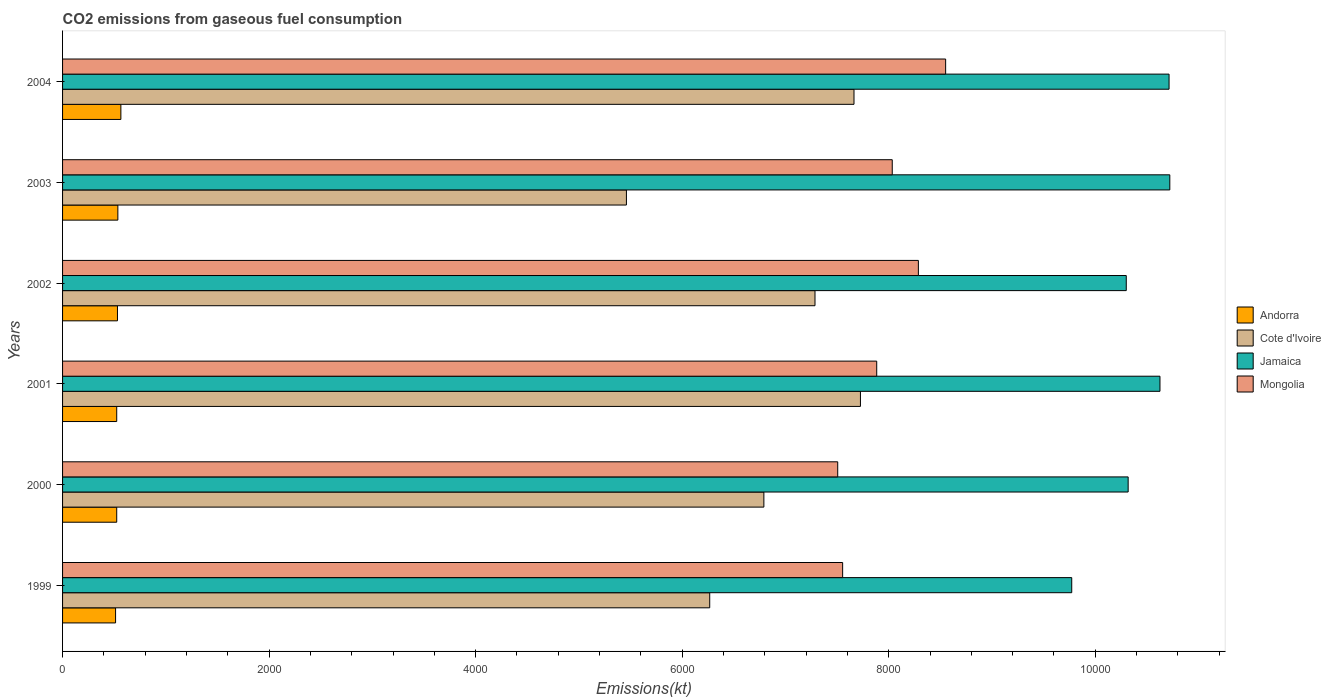How many different coloured bars are there?
Ensure brevity in your answer.  4. Are the number of bars on each tick of the Y-axis equal?
Offer a terse response. Yes. How many bars are there on the 6th tick from the top?
Offer a terse response. 4. How many bars are there on the 3rd tick from the bottom?
Offer a very short reply. 4. In how many cases, is the number of bars for a given year not equal to the number of legend labels?
Provide a short and direct response. 0. What is the amount of CO2 emitted in Mongolia in 1999?
Provide a short and direct response. 7554.02. Across all years, what is the maximum amount of CO2 emitted in Cote d'Ivoire?
Your response must be concise. 7726.37. Across all years, what is the minimum amount of CO2 emitted in Jamaica?
Your response must be concise. 9772.56. What is the total amount of CO2 emitted in Jamaica in the graph?
Your answer should be very brief. 6.25e+04. What is the difference between the amount of CO2 emitted in Mongolia in 2000 and that in 2001?
Your answer should be very brief. -377.7. What is the difference between the amount of CO2 emitted in Mongolia in 2003 and the amount of CO2 emitted in Jamaica in 2002?
Keep it short and to the point. -2266.21. What is the average amount of CO2 emitted in Jamaica per year?
Offer a terse response. 1.04e+04. In the year 2001, what is the difference between the amount of CO2 emitted in Cote d'Ivoire and amount of CO2 emitted in Jamaica?
Offer a very short reply. -2900.6. In how many years, is the amount of CO2 emitted in Cote d'Ivoire greater than 10400 kt?
Provide a short and direct response. 0. What is the ratio of the amount of CO2 emitted in Jamaica in 1999 to that in 2003?
Give a very brief answer. 0.91. Is the amount of CO2 emitted in Andorra in 2001 less than that in 2004?
Ensure brevity in your answer.  Yes. Is the difference between the amount of CO2 emitted in Cote d'Ivoire in 1999 and 2002 greater than the difference between the amount of CO2 emitted in Jamaica in 1999 and 2002?
Ensure brevity in your answer.  No. What is the difference between the highest and the second highest amount of CO2 emitted in Andorra?
Give a very brief answer. 29.34. What is the difference between the highest and the lowest amount of CO2 emitted in Mongolia?
Keep it short and to the point. 1045.09. Is the sum of the amount of CO2 emitted in Cote d'Ivoire in 1999 and 2003 greater than the maximum amount of CO2 emitted in Andorra across all years?
Make the answer very short. Yes. What does the 2nd bar from the top in 1999 represents?
Offer a very short reply. Jamaica. What does the 4th bar from the bottom in 1999 represents?
Give a very brief answer. Mongolia. How many bars are there?
Give a very brief answer. 24. Are all the bars in the graph horizontal?
Offer a terse response. Yes. What is the difference between two consecutive major ticks on the X-axis?
Offer a terse response. 2000. Are the values on the major ticks of X-axis written in scientific E-notation?
Make the answer very short. No. Does the graph contain any zero values?
Give a very brief answer. No. How many legend labels are there?
Offer a very short reply. 4. How are the legend labels stacked?
Provide a short and direct response. Vertical. What is the title of the graph?
Your response must be concise. CO2 emissions from gaseous fuel consumption. Does "Belgium" appear as one of the legend labels in the graph?
Offer a terse response. No. What is the label or title of the X-axis?
Offer a terse response. Emissions(kt). What is the Emissions(kt) in Andorra in 1999?
Your answer should be very brief. 513.38. What is the Emissions(kt) of Cote d'Ivoire in 1999?
Ensure brevity in your answer.  6266.9. What is the Emissions(kt) of Jamaica in 1999?
Make the answer very short. 9772.56. What is the Emissions(kt) of Mongolia in 1999?
Make the answer very short. 7554.02. What is the Emissions(kt) in Andorra in 2000?
Your response must be concise. 524.38. What is the Emissions(kt) of Cote d'Ivoire in 2000?
Your answer should be compact. 6791.28. What is the Emissions(kt) in Jamaica in 2000?
Offer a very short reply. 1.03e+04. What is the Emissions(kt) of Mongolia in 2000?
Keep it short and to the point. 7506.35. What is the Emissions(kt) of Andorra in 2001?
Offer a very short reply. 524.38. What is the Emissions(kt) of Cote d'Ivoire in 2001?
Your answer should be compact. 7726.37. What is the Emissions(kt) in Jamaica in 2001?
Ensure brevity in your answer.  1.06e+04. What is the Emissions(kt) in Mongolia in 2001?
Make the answer very short. 7884.05. What is the Emissions(kt) in Andorra in 2002?
Make the answer very short. 531.72. What is the Emissions(kt) of Cote d'Ivoire in 2002?
Your answer should be very brief. 7286.33. What is the Emissions(kt) in Jamaica in 2002?
Your response must be concise. 1.03e+04. What is the Emissions(kt) in Mongolia in 2002?
Ensure brevity in your answer.  8287.42. What is the Emissions(kt) of Andorra in 2003?
Give a very brief answer. 535.38. What is the Emissions(kt) of Cote d'Ivoire in 2003?
Provide a short and direct response. 5460.16. What is the Emissions(kt) of Jamaica in 2003?
Your answer should be compact. 1.07e+04. What is the Emissions(kt) of Mongolia in 2003?
Your answer should be compact. 8034.4. What is the Emissions(kt) of Andorra in 2004?
Provide a succinct answer. 564.72. What is the Emissions(kt) in Cote d'Ivoire in 2004?
Ensure brevity in your answer.  7664.03. What is the Emissions(kt) in Jamaica in 2004?
Your answer should be compact. 1.07e+04. What is the Emissions(kt) in Mongolia in 2004?
Your answer should be very brief. 8551.44. Across all years, what is the maximum Emissions(kt) of Andorra?
Provide a short and direct response. 564.72. Across all years, what is the maximum Emissions(kt) of Cote d'Ivoire?
Make the answer very short. 7726.37. Across all years, what is the maximum Emissions(kt) of Jamaica?
Offer a terse response. 1.07e+04. Across all years, what is the maximum Emissions(kt) in Mongolia?
Make the answer very short. 8551.44. Across all years, what is the minimum Emissions(kt) in Andorra?
Make the answer very short. 513.38. Across all years, what is the minimum Emissions(kt) in Cote d'Ivoire?
Provide a short and direct response. 5460.16. Across all years, what is the minimum Emissions(kt) in Jamaica?
Give a very brief answer. 9772.56. Across all years, what is the minimum Emissions(kt) of Mongolia?
Make the answer very short. 7506.35. What is the total Emissions(kt) of Andorra in the graph?
Offer a very short reply. 3193.96. What is the total Emissions(kt) of Cote d'Ivoire in the graph?
Make the answer very short. 4.12e+04. What is the total Emissions(kt) in Jamaica in the graph?
Give a very brief answer. 6.25e+04. What is the total Emissions(kt) of Mongolia in the graph?
Give a very brief answer. 4.78e+04. What is the difference between the Emissions(kt) of Andorra in 1999 and that in 2000?
Your response must be concise. -11. What is the difference between the Emissions(kt) in Cote d'Ivoire in 1999 and that in 2000?
Your response must be concise. -524.38. What is the difference between the Emissions(kt) of Jamaica in 1999 and that in 2000?
Your answer should be very brief. -546.38. What is the difference between the Emissions(kt) in Mongolia in 1999 and that in 2000?
Make the answer very short. 47.67. What is the difference between the Emissions(kt) of Andorra in 1999 and that in 2001?
Make the answer very short. -11. What is the difference between the Emissions(kt) in Cote d'Ivoire in 1999 and that in 2001?
Your answer should be compact. -1459.47. What is the difference between the Emissions(kt) in Jamaica in 1999 and that in 2001?
Offer a terse response. -854.41. What is the difference between the Emissions(kt) in Mongolia in 1999 and that in 2001?
Keep it short and to the point. -330.03. What is the difference between the Emissions(kt) of Andorra in 1999 and that in 2002?
Offer a very short reply. -18.34. What is the difference between the Emissions(kt) in Cote d'Ivoire in 1999 and that in 2002?
Offer a terse response. -1019.43. What is the difference between the Emissions(kt) of Jamaica in 1999 and that in 2002?
Your response must be concise. -528.05. What is the difference between the Emissions(kt) of Mongolia in 1999 and that in 2002?
Offer a terse response. -733.4. What is the difference between the Emissions(kt) in Andorra in 1999 and that in 2003?
Offer a very short reply. -22. What is the difference between the Emissions(kt) of Cote d'Ivoire in 1999 and that in 2003?
Keep it short and to the point. 806.74. What is the difference between the Emissions(kt) of Jamaica in 1999 and that in 2003?
Your answer should be compact. -949.75. What is the difference between the Emissions(kt) of Mongolia in 1999 and that in 2003?
Offer a very short reply. -480.38. What is the difference between the Emissions(kt) in Andorra in 1999 and that in 2004?
Ensure brevity in your answer.  -51.34. What is the difference between the Emissions(kt) in Cote d'Ivoire in 1999 and that in 2004?
Give a very brief answer. -1397.13. What is the difference between the Emissions(kt) in Jamaica in 1999 and that in 2004?
Offer a very short reply. -942.42. What is the difference between the Emissions(kt) in Mongolia in 1999 and that in 2004?
Your answer should be compact. -997.42. What is the difference between the Emissions(kt) in Cote d'Ivoire in 2000 and that in 2001?
Provide a succinct answer. -935.09. What is the difference between the Emissions(kt) of Jamaica in 2000 and that in 2001?
Your answer should be very brief. -308.03. What is the difference between the Emissions(kt) of Mongolia in 2000 and that in 2001?
Make the answer very short. -377.7. What is the difference between the Emissions(kt) of Andorra in 2000 and that in 2002?
Provide a short and direct response. -7.33. What is the difference between the Emissions(kt) of Cote d'Ivoire in 2000 and that in 2002?
Offer a terse response. -495.05. What is the difference between the Emissions(kt) of Jamaica in 2000 and that in 2002?
Your answer should be compact. 18.34. What is the difference between the Emissions(kt) of Mongolia in 2000 and that in 2002?
Your response must be concise. -781.07. What is the difference between the Emissions(kt) of Andorra in 2000 and that in 2003?
Make the answer very short. -11. What is the difference between the Emissions(kt) of Cote d'Ivoire in 2000 and that in 2003?
Provide a succinct answer. 1331.12. What is the difference between the Emissions(kt) of Jamaica in 2000 and that in 2003?
Your answer should be compact. -403.37. What is the difference between the Emissions(kt) in Mongolia in 2000 and that in 2003?
Offer a terse response. -528.05. What is the difference between the Emissions(kt) of Andorra in 2000 and that in 2004?
Provide a short and direct response. -40.34. What is the difference between the Emissions(kt) of Cote d'Ivoire in 2000 and that in 2004?
Offer a terse response. -872.75. What is the difference between the Emissions(kt) of Jamaica in 2000 and that in 2004?
Offer a terse response. -396.04. What is the difference between the Emissions(kt) of Mongolia in 2000 and that in 2004?
Offer a very short reply. -1045.1. What is the difference between the Emissions(kt) of Andorra in 2001 and that in 2002?
Your response must be concise. -7.33. What is the difference between the Emissions(kt) in Cote d'Ivoire in 2001 and that in 2002?
Keep it short and to the point. 440.04. What is the difference between the Emissions(kt) in Jamaica in 2001 and that in 2002?
Give a very brief answer. 326.36. What is the difference between the Emissions(kt) of Mongolia in 2001 and that in 2002?
Ensure brevity in your answer.  -403.37. What is the difference between the Emissions(kt) of Andorra in 2001 and that in 2003?
Provide a short and direct response. -11. What is the difference between the Emissions(kt) in Cote d'Ivoire in 2001 and that in 2003?
Your response must be concise. 2266.21. What is the difference between the Emissions(kt) of Jamaica in 2001 and that in 2003?
Ensure brevity in your answer.  -95.34. What is the difference between the Emissions(kt) of Mongolia in 2001 and that in 2003?
Offer a terse response. -150.35. What is the difference between the Emissions(kt) of Andorra in 2001 and that in 2004?
Give a very brief answer. -40.34. What is the difference between the Emissions(kt) of Cote d'Ivoire in 2001 and that in 2004?
Make the answer very short. 62.34. What is the difference between the Emissions(kt) in Jamaica in 2001 and that in 2004?
Make the answer very short. -88.01. What is the difference between the Emissions(kt) in Mongolia in 2001 and that in 2004?
Offer a very short reply. -667.39. What is the difference between the Emissions(kt) in Andorra in 2002 and that in 2003?
Give a very brief answer. -3.67. What is the difference between the Emissions(kt) in Cote d'Ivoire in 2002 and that in 2003?
Your answer should be very brief. 1826.17. What is the difference between the Emissions(kt) in Jamaica in 2002 and that in 2003?
Your response must be concise. -421.7. What is the difference between the Emissions(kt) of Mongolia in 2002 and that in 2003?
Make the answer very short. 253.02. What is the difference between the Emissions(kt) of Andorra in 2002 and that in 2004?
Your answer should be compact. -33. What is the difference between the Emissions(kt) of Cote d'Ivoire in 2002 and that in 2004?
Your answer should be very brief. -377.7. What is the difference between the Emissions(kt) of Jamaica in 2002 and that in 2004?
Your response must be concise. -414.37. What is the difference between the Emissions(kt) in Mongolia in 2002 and that in 2004?
Give a very brief answer. -264.02. What is the difference between the Emissions(kt) of Andorra in 2003 and that in 2004?
Provide a short and direct response. -29.34. What is the difference between the Emissions(kt) of Cote d'Ivoire in 2003 and that in 2004?
Ensure brevity in your answer.  -2203.87. What is the difference between the Emissions(kt) in Jamaica in 2003 and that in 2004?
Keep it short and to the point. 7.33. What is the difference between the Emissions(kt) in Mongolia in 2003 and that in 2004?
Offer a very short reply. -517.05. What is the difference between the Emissions(kt) in Andorra in 1999 and the Emissions(kt) in Cote d'Ivoire in 2000?
Offer a terse response. -6277.9. What is the difference between the Emissions(kt) of Andorra in 1999 and the Emissions(kt) of Jamaica in 2000?
Offer a very short reply. -9805.56. What is the difference between the Emissions(kt) in Andorra in 1999 and the Emissions(kt) in Mongolia in 2000?
Your response must be concise. -6992.97. What is the difference between the Emissions(kt) of Cote d'Ivoire in 1999 and the Emissions(kt) of Jamaica in 2000?
Provide a short and direct response. -4052.03. What is the difference between the Emissions(kt) in Cote d'Ivoire in 1999 and the Emissions(kt) in Mongolia in 2000?
Offer a very short reply. -1239.45. What is the difference between the Emissions(kt) of Jamaica in 1999 and the Emissions(kt) of Mongolia in 2000?
Offer a very short reply. 2266.21. What is the difference between the Emissions(kt) in Andorra in 1999 and the Emissions(kt) in Cote d'Ivoire in 2001?
Offer a very short reply. -7212.99. What is the difference between the Emissions(kt) of Andorra in 1999 and the Emissions(kt) of Jamaica in 2001?
Make the answer very short. -1.01e+04. What is the difference between the Emissions(kt) in Andorra in 1999 and the Emissions(kt) in Mongolia in 2001?
Offer a terse response. -7370.67. What is the difference between the Emissions(kt) of Cote d'Ivoire in 1999 and the Emissions(kt) of Jamaica in 2001?
Offer a terse response. -4360.06. What is the difference between the Emissions(kt) of Cote d'Ivoire in 1999 and the Emissions(kt) of Mongolia in 2001?
Your answer should be compact. -1617.15. What is the difference between the Emissions(kt) of Jamaica in 1999 and the Emissions(kt) of Mongolia in 2001?
Make the answer very short. 1888.51. What is the difference between the Emissions(kt) of Andorra in 1999 and the Emissions(kt) of Cote d'Ivoire in 2002?
Make the answer very short. -6772.95. What is the difference between the Emissions(kt) of Andorra in 1999 and the Emissions(kt) of Jamaica in 2002?
Keep it short and to the point. -9787.22. What is the difference between the Emissions(kt) in Andorra in 1999 and the Emissions(kt) in Mongolia in 2002?
Ensure brevity in your answer.  -7774.04. What is the difference between the Emissions(kt) in Cote d'Ivoire in 1999 and the Emissions(kt) in Jamaica in 2002?
Keep it short and to the point. -4033.7. What is the difference between the Emissions(kt) of Cote d'Ivoire in 1999 and the Emissions(kt) of Mongolia in 2002?
Provide a short and direct response. -2020.52. What is the difference between the Emissions(kt) in Jamaica in 1999 and the Emissions(kt) in Mongolia in 2002?
Provide a short and direct response. 1485.13. What is the difference between the Emissions(kt) of Andorra in 1999 and the Emissions(kt) of Cote d'Ivoire in 2003?
Give a very brief answer. -4946.78. What is the difference between the Emissions(kt) in Andorra in 1999 and the Emissions(kt) in Jamaica in 2003?
Your response must be concise. -1.02e+04. What is the difference between the Emissions(kt) of Andorra in 1999 and the Emissions(kt) of Mongolia in 2003?
Make the answer very short. -7521.02. What is the difference between the Emissions(kt) in Cote d'Ivoire in 1999 and the Emissions(kt) in Jamaica in 2003?
Your answer should be compact. -4455.4. What is the difference between the Emissions(kt) of Cote d'Ivoire in 1999 and the Emissions(kt) of Mongolia in 2003?
Provide a succinct answer. -1767.49. What is the difference between the Emissions(kt) of Jamaica in 1999 and the Emissions(kt) of Mongolia in 2003?
Your answer should be compact. 1738.16. What is the difference between the Emissions(kt) in Andorra in 1999 and the Emissions(kt) in Cote d'Ivoire in 2004?
Make the answer very short. -7150.65. What is the difference between the Emissions(kt) of Andorra in 1999 and the Emissions(kt) of Jamaica in 2004?
Your answer should be very brief. -1.02e+04. What is the difference between the Emissions(kt) in Andorra in 1999 and the Emissions(kt) in Mongolia in 2004?
Your answer should be compact. -8038.06. What is the difference between the Emissions(kt) of Cote d'Ivoire in 1999 and the Emissions(kt) of Jamaica in 2004?
Ensure brevity in your answer.  -4448.07. What is the difference between the Emissions(kt) of Cote d'Ivoire in 1999 and the Emissions(kt) of Mongolia in 2004?
Your response must be concise. -2284.54. What is the difference between the Emissions(kt) in Jamaica in 1999 and the Emissions(kt) in Mongolia in 2004?
Provide a succinct answer. 1221.11. What is the difference between the Emissions(kt) of Andorra in 2000 and the Emissions(kt) of Cote d'Ivoire in 2001?
Provide a short and direct response. -7201.99. What is the difference between the Emissions(kt) in Andorra in 2000 and the Emissions(kt) in Jamaica in 2001?
Provide a succinct answer. -1.01e+04. What is the difference between the Emissions(kt) of Andorra in 2000 and the Emissions(kt) of Mongolia in 2001?
Offer a terse response. -7359.67. What is the difference between the Emissions(kt) in Cote d'Ivoire in 2000 and the Emissions(kt) in Jamaica in 2001?
Offer a very short reply. -3835.68. What is the difference between the Emissions(kt) in Cote d'Ivoire in 2000 and the Emissions(kt) in Mongolia in 2001?
Provide a short and direct response. -1092.77. What is the difference between the Emissions(kt) of Jamaica in 2000 and the Emissions(kt) of Mongolia in 2001?
Offer a terse response. 2434.89. What is the difference between the Emissions(kt) of Andorra in 2000 and the Emissions(kt) of Cote d'Ivoire in 2002?
Offer a terse response. -6761.95. What is the difference between the Emissions(kt) of Andorra in 2000 and the Emissions(kt) of Jamaica in 2002?
Ensure brevity in your answer.  -9776.22. What is the difference between the Emissions(kt) of Andorra in 2000 and the Emissions(kt) of Mongolia in 2002?
Provide a short and direct response. -7763.04. What is the difference between the Emissions(kt) of Cote d'Ivoire in 2000 and the Emissions(kt) of Jamaica in 2002?
Make the answer very short. -3509.32. What is the difference between the Emissions(kt) of Cote d'Ivoire in 2000 and the Emissions(kt) of Mongolia in 2002?
Make the answer very short. -1496.14. What is the difference between the Emissions(kt) of Jamaica in 2000 and the Emissions(kt) of Mongolia in 2002?
Keep it short and to the point. 2031.52. What is the difference between the Emissions(kt) in Andorra in 2000 and the Emissions(kt) in Cote d'Ivoire in 2003?
Offer a terse response. -4935.78. What is the difference between the Emissions(kt) of Andorra in 2000 and the Emissions(kt) of Jamaica in 2003?
Provide a succinct answer. -1.02e+04. What is the difference between the Emissions(kt) of Andorra in 2000 and the Emissions(kt) of Mongolia in 2003?
Give a very brief answer. -7510.02. What is the difference between the Emissions(kt) of Cote d'Ivoire in 2000 and the Emissions(kt) of Jamaica in 2003?
Ensure brevity in your answer.  -3931.02. What is the difference between the Emissions(kt) of Cote d'Ivoire in 2000 and the Emissions(kt) of Mongolia in 2003?
Offer a very short reply. -1243.11. What is the difference between the Emissions(kt) of Jamaica in 2000 and the Emissions(kt) of Mongolia in 2003?
Offer a terse response. 2284.54. What is the difference between the Emissions(kt) of Andorra in 2000 and the Emissions(kt) of Cote d'Ivoire in 2004?
Ensure brevity in your answer.  -7139.65. What is the difference between the Emissions(kt) in Andorra in 2000 and the Emissions(kt) in Jamaica in 2004?
Keep it short and to the point. -1.02e+04. What is the difference between the Emissions(kt) in Andorra in 2000 and the Emissions(kt) in Mongolia in 2004?
Your answer should be very brief. -8027.06. What is the difference between the Emissions(kt) of Cote d'Ivoire in 2000 and the Emissions(kt) of Jamaica in 2004?
Give a very brief answer. -3923.69. What is the difference between the Emissions(kt) of Cote d'Ivoire in 2000 and the Emissions(kt) of Mongolia in 2004?
Keep it short and to the point. -1760.16. What is the difference between the Emissions(kt) of Jamaica in 2000 and the Emissions(kt) of Mongolia in 2004?
Offer a very short reply. 1767.49. What is the difference between the Emissions(kt) of Andorra in 2001 and the Emissions(kt) of Cote d'Ivoire in 2002?
Your answer should be compact. -6761.95. What is the difference between the Emissions(kt) of Andorra in 2001 and the Emissions(kt) of Jamaica in 2002?
Provide a succinct answer. -9776.22. What is the difference between the Emissions(kt) of Andorra in 2001 and the Emissions(kt) of Mongolia in 2002?
Your response must be concise. -7763.04. What is the difference between the Emissions(kt) in Cote d'Ivoire in 2001 and the Emissions(kt) in Jamaica in 2002?
Offer a terse response. -2574.23. What is the difference between the Emissions(kt) in Cote d'Ivoire in 2001 and the Emissions(kt) in Mongolia in 2002?
Keep it short and to the point. -561.05. What is the difference between the Emissions(kt) in Jamaica in 2001 and the Emissions(kt) in Mongolia in 2002?
Make the answer very short. 2339.55. What is the difference between the Emissions(kt) in Andorra in 2001 and the Emissions(kt) in Cote d'Ivoire in 2003?
Offer a very short reply. -4935.78. What is the difference between the Emissions(kt) of Andorra in 2001 and the Emissions(kt) of Jamaica in 2003?
Offer a very short reply. -1.02e+04. What is the difference between the Emissions(kt) of Andorra in 2001 and the Emissions(kt) of Mongolia in 2003?
Offer a very short reply. -7510.02. What is the difference between the Emissions(kt) of Cote d'Ivoire in 2001 and the Emissions(kt) of Jamaica in 2003?
Your response must be concise. -2995.94. What is the difference between the Emissions(kt) in Cote d'Ivoire in 2001 and the Emissions(kt) in Mongolia in 2003?
Give a very brief answer. -308.03. What is the difference between the Emissions(kt) of Jamaica in 2001 and the Emissions(kt) of Mongolia in 2003?
Give a very brief answer. 2592.57. What is the difference between the Emissions(kt) of Andorra in 2001 and the Emissions(kt) of Cote d'Ivoire in 2004?
Offer a terse response. -7139.65. What is the difference between the Emissions(kt) of Andorra in 2001 and the Emissions(kt) of Jamaica in 2004?
Keep it short and to the point. -1.02e+04. What is the difference between the Emissions(kt) in Andorra in 2001 and the Emissions(kt) in Mongolia in 2004?
Provide a succinct answer. -8027.06. What is the difference between the Emissions(kt) of Cote d'Ivoire in 2001 and the Emissions(kt) of Jamaica in 2004?
Offer a very short reply. -2988.61. What is the difference between the Emissions(kt) in Cote d'Ivoire in 2001 and the Emissions(kt) in Mongolia in 2004?
Your response must be concise. -825.08. What is the difference between the Emissions(kt) of Jamaica in 2001 and the Emissions(kt) of Mongolia in 2004?
Offer a terse response. 2075.52. What is the difference between the Emissions(kt) of Andorra in 2002 and the Emissions(kt) of Cote d'Ivoire in 2003?
Give a very brief answer. -4928.45. What is the difference between the Emissions(kt) in Andorra in 2002 and the Emissions(kt) in Jamaica in 2003?
Your answer should be compact. -1.02e+04. What is the difference between the Emissions(kt) in Andorra in 2002 and the Emissions(kt) in Mongolia in 2003?
Provide a short and direct response. -7502.68. What is the difference between the Emissions(kt) in Cote d'Ivoire in 2002 and the Emissions(kt) in Jamaica in 2003?
Your answer should be compact. -3435.98. What is the difference between the Emissions(kt) of Cote d'Ivoire in 2002 and the Emissions(kt) of Mongolia in 2003?
Make the answer very short. -748.07. What is the difference between the Emissions(kt) of Jamaica in 2002 and the Emissions(kt) of Mongolia in 2003?
Provide a short and direct response. 2266.21. What is the difference between the Emissions(kt) of Andorra in 2002 and the Emissions(kt) of Cote d'Ivoire in 2004?
Your answer should be compact. -7132.31. What is the difference between the Emissions(kt) of Andorra in 2002 and the Emissions(kt) of Jamaica in 2004?
Offer a very short reply. -1.02e+04. What is the difference between the Emissions(kt) of Andorra in 2002 and the Emissions(kt) of Mongolia in 2004?
Make the answer very short. -8019.73. What is the difference between the Emissions(kt) in Cote d'Ivoire in 2002 and the Emissions(kt) in Jamaica in 2004?
Make the answer very short. -3428.64. What is the difference between the Emissions(kt) in Cote d'Ivoire in 2002 and the Emissions(kt) in Mongolia in 2004?
Ensure brevity in your answer.  -1265.12. What is the difference between the Emissions(kt) in Jamaica in 2002 and the Emissions(kt) in Mongolia in 2004?
Keep it short and to the point. 1749.16. What is the difference between the Emissions(kt) in Andorra in 2003 and the Emissions(kt) in Cote d'Ivoire in 2004?
Ensure brevity in your answer.  -7128.65. What is the difference between the Emissions(kt) in Andorra in 2003 and the Emissions(kt) in Jamaica in 2004?
Your answer should be compact. -1.02e+04. What is the difference between the Emissions(kt) in Andorra in 2003 and the Emissions(kt) in Mongolia in 2004?
Offer a very short reply. -8016.06. What is the difference between the Emissions(kt) of Cote d'Ivoire in 2003 and the Emissions(kt) of Jamaica in 2004?
Provide a succinct answer. -5254.81. What is the difference between the Emissions(kt) of Cote d'Ivoire in 2003 and the Emissions(kt) of Mongolia in 2004?
Offer a terse response. -3091.28. What is the difference between the Emissions(kt) in Jamaica in 2003 and the Emissions(kt) in Mongolia in 2004?
Provide a succinct answer. 2170.86. What is the average Emissions(kt) of Andorra per year?
Make the answer very short. 532.33. What is the average Emissions(kt) in Cote d'Ivoire per year?
Offer a very short reply. 6865.85. What is the average Emissions(kt) in Jamaica per year?
Provide a short and direct response. 1.04e+04. What is the average Emissions(kt) in Mongolia per year?
Make the answer very short. 7969.61. In the year 1999, what is the difference between the Emissions(kt) in Andorra and Emissions(kt) in Cote d'Ivoire?
Your answer should be very brief. -5753.52. In the year 1999, what is the difference between the Emissions(kt) of Andorra and Emissions(kt) of Jamaica?
Your response must be concise. -9259.17. In the year 1999, what is the difference between the Emissions(kt) of Andorra and Emissions(kt) of Mongolia?
Offer a very short reply. -7040.64. In the year 1999, what is the difference between the Emissions(kt) in Cote d'Ivoire and Emissions(kt) in Jamaica?
Offer a terse response. -3505.65. In the year 1999, what is the difference between the Emissions(kt) in Cote d'Ivoire and Emissions(kt) in Mongolia?
Ensure brevity in your answer.  -1287.12. In the year 1999, what is the difference between the Emissions(kt) in Jamaica and Emissions(kt) in Mongolia?
Provide a succinct answer. 2218.53. In the year 2000, what is the difference between the Emissions(kt) in Andorra and Emissions(kt) in Cote d'Ivoire?
Offer a terse response. -6266.9. In the year 2000, what is the difference between the Emissions(kt) of Andorra and Emissions(kt) of Jamaica?
Your answer should be very brief. -9794.56. In the year 2000, what is the difference between the Emissions(kt) of Andorra and Emissions(kt) of Mongolia?
Your response must be concise. -6981.97. In the year 2000, what is the difference between the Emissions(kt) of Cote d'Ivoire and Emissions(kt) of Jamaica?
Your answer should be very brief. -3527.65. In the year 2000, what is the difference between the Emissions(kt) of Cote d'Ivoire and Emissions(kt) of Mongolia?
Offer a very short reply. -715.07. In the year 2000, what is the difference between the Emissions(kt) in Jamaica and Emissions(kt) in Mongolia?
Provide a short and direct response. 2812.59. In the year 2001, what is the difference between the Emissions(kt) of Andorra and Emissions(kt) of Cote d'Ivoire?
Offer a very short reply. -7201.99. In the year 2001, what is the difference between the Emissions(kt) of Andorra and Emissions(kt) of Jamaica?
Give a very brief answer. -1.01e+04. In the year 2001, what is the difference between the Emissions(kt) of Andorra and Emissions(kt) of Mongolia?
Ensure brevity in your answer.  -7359.67. In the year 2001, what is the difference between the Emissions(kt) in Cote d'Ivoire and Emissions(kt) in Jamaica?
Keep it short and to the point. -2900.6. In the year 2001, what is the difference between the Emissions(kt) of Cote d'Ivoire and Emissions(kt) of Mongolia?
Keep it short and to the point. -157.68. In the year 2001, what is the difference between the Emissions(kt) of Jamaica and Emissions(kt) of Mongolia?
Provide a succinct answer. 2742.92. In the year 2002, what is the difference between the Emissions(kt) of Andorra and Emissions(kt) of Cote d'Ivoire?
Your response must be concise. -6754.61. In the year 2002, what is the difference between the Emissions(kt) in Andorra and Emissions(kt) in Jamaica?
Make the answer very short. -9768.89. In the year 2002, what is the difference between the Emissions(kt) in Andorra and Emissions(kt) in Mongolia?
Keep it short and to the point. -7755.7. In the year 2002, what is the difference between the Emissions(kt) in Cote d'Ivoire and Emissions(kt) in Jamaica?
Offer a terse response. -3014.27. In the year 2002, what is the difference between the Emissions(kt) of Cote d'Ivoire and Emissions(kt) of Mongolia?
Provide a short and direct response. -1001.09. In the year 2002, what is the difference between the Emissions(kt) in Jamaica and Emissions(kt) in Mongolia?
Provide a short and direct response. 2013.18. In the year 2003, what is the difference between the Emissions(kt) in Andorra and Emissions(kt) in Cote d'Ivoire?
Provide a short and direct response. -4924.78. In the year 2003, what is the difference between the Emissions(kt) in Andorra and Emissions(kt) in Jamaica?
Offer a very short reply. -1.02e+04. In the year 2003, what is the difference between the Emissions(kt) of Andorra and Emissions(kt) of Mongolia?
Keep it short and to the point. -7499.02. In the year 2003, what is the difference between the Emissions(kt) of Cote d'Ivoire and Emissions(kt) of Jamaica?
Offer a terse response. -5262.15. In the year 2003, what is the difference between the Emissions(kt) of Cote d'Ivoire and Emissions(kt) of Mongolia?
Provide a succinct answer. -2574.23. In the year 2003, what is the difference between the Emissions(kt) in Jamaica and Emissions(kt) in Mongolia?
Offer a very short reply. 2687.91. In the year 2004, what is the difference between the Emissions(kt) of Andorra and Emissions(kt) of Cote d'Ivoire?
Provide a short and direct response. -7099.31. In the year 2004, what is the difference between the Emissions(kt) in Andorra and Emissions(kt) in Jamaica?
Provide a short and direct response. -1.02e+04. In the year 2004, what is the difference between the Emissions(kt) of Andorra and Emissions(kt) of Mongolia?
Your answer should be very brief. -7986.73. In the year 2004, what is the difference between the Emissions(kt) in Cote d'Ivoire and Emissions(kt) in Jamaica?
Your answer should be compact. -3050.94. In the year 2004, what is the difference between the Emissions(kt) of Cote d'Ivoire and Emissions(kt) of Mongolia?
Keep it short and to the point. -887.41. In the year 2004, what is the difference between the Emissions(kt) in Jamaica and Emissions(kt) in Mongolia?
Your answer should be very brief. 2163.53. What is the ratio of the Emissions(kt) in Andorra in 1999 to that in 2000?
Your response must be concise. 0.98. What is the ratio of the Emissions(kt) in Cote d'Ivoire in 1999 to that in 2000?
Offer a terse response. 0.92. What is the ratio of the Emissions(kt) in Jamaica in 1999 to that in 2000?
Offer a very short reply. 0.95. What is the ratio of the Emissions(kt) in Mongolia in 1999 to that in 2000?
Your answer should be very brief. 1.01. What is the ratio of the Emissions(kt) of Andorra in 1999 to that in 2001?
Your answer should be compact. 0.98. What is the ratio of the Emissions(kt) of Cote d'Ivoire in 1999 to that in 2001?
Ensure brevity in your answer.  0.81. What is the ratio of the Emissions(kt) of Jamaica in 1999 to that in 2001?
Ensure brevity in your answer.  0.92. What is the ratio of the Emissions(kt) of Mongolia in 1999 to that in 2001?
Ensure brevity in your answer.  0.96. What is the ratio of the Emissions(kt) of Andorra in 1999 to that in 2002?
Provide a short and direct response. 0.97. What is the ratio of the Emissions(kt) in Cote d'Ivoire in 1999 to that in 2002?
Offer a terse response. 0.86. What is the ratio of the Emissions(kt) of Jamaica in 1999 to that in 2002?
Your answer should be compact. 0.95. What is the ratio of the Emissions(kt) in Mongolia in 1999 to that in 2002?
Provide a short and direct response. 0.91. What is the ratio of the Emissions(kt) of Andorra in 1999 to that in 2003?
Your answer should be very brief. 0.96. What is the ratio of the Emissions(kt) in Cote d'Ivoire in 1999 to that in 2003?
Ensure brevity in your answer.  1.15. What is the ratio of the Emissions(kt) in Jamaica in 1999 to that in 2003?
Provide a succinct answer. 0.91. What is the ratio of the Emissions(kt) in Mongolia in 1999 to that in 2003?
Give a very brief answer. 0.94. What is the ratio of the Emissions(kt) of Andorra in 1999 to that in 2004?
Keep it short and to the point. 0.91. What is the ratio of the Emissions(kt) in Cote d'Ivoire in 1999 to that in 2004?
Make the answer very short. 0.82. What is the ratio of the Emissions(kt) in Jamaica in 1999 to that in 2004?
Keep it short and to the point. 0.91. What is the ratio of the Emissions(kt) of Mongolia in 1999 to that in 2004?
Make the answer very short. 0.88. What is the ratio of the Emissions(kt) in Cote d'Ivoire in 2000 to that in 2001?
Provide a short and direct response. 0.88. What is the ratio of the Emissions(kt) in Mongolia in 2000 to that in 2001?
Your response must be concise. 0.95. What is the ratio of the Emissions(kt) in Andorra in 2000 to that in 2002?
Your answer should be very brief. 0.99. What is the ratio of the Emissions(kt) of Cote d'Ivoire in 2000 to that in 2002?
Your response must be concise. 0.93. What is the ratio of the Emissions(kt) of Jamaica in 2000 to that in 2002?
Offer a very short reply. 1. What is the ratio of the Emissions(kt) in Mongolia in 2000 to that in 2002?
Your response must be concise. 0.91. What is the ratio of the Emissions(kt) in Andorra in 2000 to that in 2003?
Your answer should be very brief. 0.98. What is the ratio of the Emissions(kt) in Cote d'Ivoire in 2000 to that in 2003?
Give a very brief answer. 1.24. What is the ratio of the Emissions(kt) of Jamaica in 2000 to that in 2003?
Make the answer very short. 0.96. What is the ratio of the Emissions(kt) in Mongolia in 2000 to that in 2003?
Your answer should be compact. 0.93. What is the ratio of the Emissions(kt) of Andorra in 2000 to that in 2004?
Provide a short and direct response. 0.93. What is the ratio of the Emissions(kt) in Cote d'Ivoire in 2000 to that in 2004?
Make the answer very short. 0.89. What is the ratio of the Emissions(kt) of Mongolia in 2000 to that in 2004?
Your response must be concise. 0.88. What is the ratio of the Emissions(kt) of Andorra in 2001 to that in 2002?
Keep it short and to the point. 0.99. What is the ratio of the Emissions(kt) in Cote d'Ivoire in 2001 to that in 2002?
Your response must be concise. 1.06. What is the ratio of the Emissions(kt) in Jamaica in 2001 to that in 2002?
Ensure brevity in your answer.  1.03. What is the ratio of the Emissions(kt) of Mongolia in 2001 to that in 2002?
Make the answer very short. 0.95. What is the ratio of the Emissions(kt) of Andorra in 2001 to that in 2003?
Offer a terse response. 0.98. What is the ratio of the Emissions(kt) in Cote d'Ivoire in 2001 to that in 2003?
Provide a succinct answer. 1.42. What is the ratio of the Emissions(kt) of Mongolia in 2001 to that in 2003?
Your answer should be compact. 0.98. What is the ratio of the Emissions(kt) in Jamaica in 2001 to that in 2004?
Make the answer very short. 0.99. What is the ratio of the Emissions(kt) of Mongolia in 2001 to that in 2004?
Provide a succinct answer. 0.92. What is the ratio of the Emissions(kt) of Andorra in 2002 to that in 2003?
Your answer should be compact. 0.99. What is the ratio of the Emissions(kt) of Cote d'Ivoire in 2002 to that in 2003?
Your answer should be compact. 1.33. What is the ratio of the Emissions(kt) in Jamaica in 2002 to that in 2003?
Offer a very short reply. 0.96. What is the ratio of the Emissions(kt) in Mongolia in 2002 to that in 2003?
Offer a very short reply. 1.03. What is the ratio of the Emissions(kt) in Andorra in 2002 to that in 2004?
Your answer should be very brief. 0.94. What is the ratio of the Emissions(kt) of Cote d'Ivoire in 2002 to that in 2004?
Give a very brief answer. 0.95. What is the ratio of the Emissions(kt) of Jamaica in 2002 to that in 2004?
Offer a terse response. 0.96. What is the ratio of the Emissions(kt) in Mongolia in 2002 to that in 2004?
Your answer should be compact. 0.97. What is the ratio of the Emissions(kt) in Andorra in 2003 to that in 2004?
Your response must be concise. 0.95. What is the ratio of the Emissions(kt) in Cote d'Ivoire in 2003 to that in 2004?
Keep it short and to the point. 0.71. What is the ratio of the Emissions(kt) of Mongolia in 2003 to that in 2004?
Ensure brevity in your answer.  0.94. What is the difference between the highest and the second highest Emissions(kt) in Andorra?
Provide a short and direct response. 29.34. What is the difference between the highest and the second highest Emissions(kt) in Cote d'Ivoire?
Ensure brevity in your answer.  62.34. What is the difference between the highest and the second highest Emissions(kt) in Jamaica?
Ensure brevity in your answer.  7.33. What is the difference between the highest and the second highest Emissions(kt) of Mongolia?
Provide a succinct answer. 264.02. What is the difference between the highest and the lowest Emissions(kt) in Andorra?
Offer a very short reply. 51.34. What is the difference between the highest and the lowest Emissions(kt) of Cote d'Ivoire?
Provide a short and direct response. 2266.21. What is the difference between the highest and the lowest Emissions(kt) in Jamaica?
Your response must be concise. 949.75. What is the difference between the highest and the lowest Emissions(kt) of Mongolia?
Ensure brevity in your answer.  1045.1. 